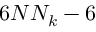<formula> <loc_0><loc_0><loc_500><loc_500>6 N N _ { k } - 6</formula> 